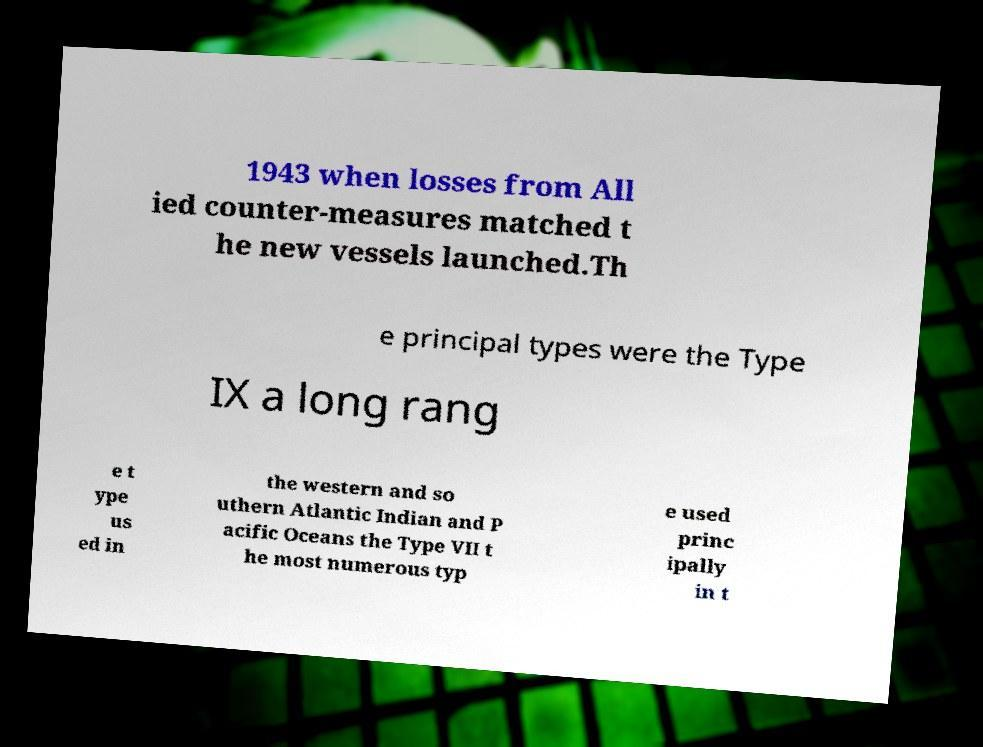For documentation purposes, I need the text within this image transcribed. Could you provide that? 1943 when losses from All ied counter-measures matched t he new vessels launched.Th e principal types were the Type IX a long rang e t ype us ed in the western and so uthern Atlantic Indian and P acific Oceans the Type VII t he most numerous typ e used princ ipally in t 